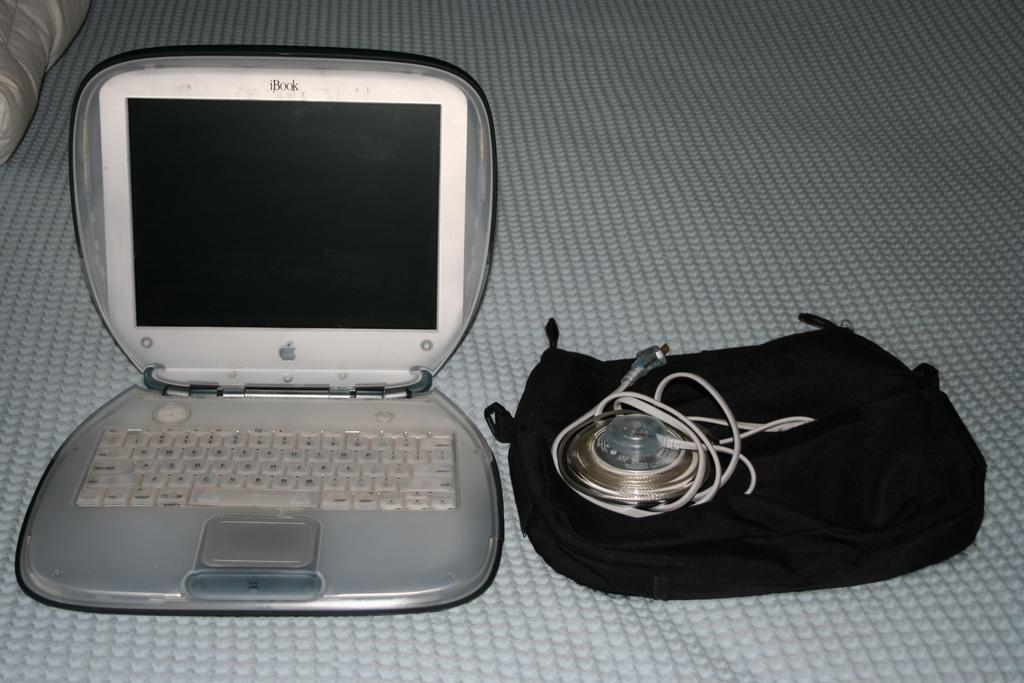What electronic device is visible in the image? There is a laptop in the image. What else can be seen in the image besides the laptop? There are wires and other objects on a surface in the image. What type of property is being discussed in the image? There is no discussion of property in the image; it primarily features a laptop and other objects. 